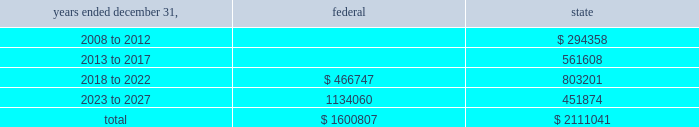American tower corporation and subsidiaries notes to consolidated financial statements 2014 ( continued ) for the years ended december 31 , 2007 and 2006 , the company increased net deferred tax assets by $ 1.5 million and $ 7.2 million , respectively with a corresponding reduction of goodwill associated with the utilization of net operating and capital losses acquired in connection with the spectrasite , inc .
Merger .
These deferred tax assets were assigned a full valuation allowance as part of the final spectrasite purchase price allocation in june 2006 , as evidence available at the time did not support that losses were more likely than not to be realized .
The valuation allowance decreased from $ 308.2 million as of december 31 , 2006 to $ 88.2 million as of december 31 , 2007 .
The decrease was primarily due to a $ 149.6 million reclassification to the fin 48 opening balance ( related to federal and state net operating losses acquired in connection with the spectrasite , inc .
Merger ) and $ 45.2 million of allowance reductions during the year ended december 31 , 2007 related to state net operating losses , capital loss expirations of $ 6.5 million and other items .
The company 2019s deferred tax assets as of december 31 , 2007 and 2006 in the table above do not include $ 74.9 million and $ 31.0 million , respectively , of excess tax benefits from the exercises of employee stock options that are a component of net operating losses due to the adoption of sfas no .
123r .
Total stockholders 2019 equity will be increased by $ 74.9 million if and when any such excess tax benefits are ultimately realized .
Basis step-up from corporate restructuring represents the tax effects of increasing the basis for tax purposes of certain of the company 2019s assets in conjunction with its spin-off from american radio systems corporation , its former parent company .
At december 31 , 2007 , the company had net federal and state operating loss carryforwards available to reduce future federal and state taxable income of approximately $ 1.6 billion and $ 2.1 billion , respectively .
If not utilized , the company 2019s net operating loss carryforwards expire as follows ( in thousands ) : .
As described in note 1 , the company adopted the provisions of fin 48 on january 1 , 2007 .
As of january 1 , 2007 , the total amount of unrecognized tax benefits was $ 183.9 million of which $ 34.3 million would affect the effective tax rate , if recognized .
As of december 31 , 2007 , the total amount of unrecognized tax benefits was $ 59.2 million , $ 23.0 million of which would affect the effective tax rate , if recognized .
The company expects the unrecognized tax benefits to change over the next 12 months if certain tax matters ultimately settle with the applicable taxing jurisdiction during this timeframe .
However , based on the status of these items and the amount of uncertainty associated with the outcome and timing of audit settlements , the .
What was the change in the total amount of unrecognized tax benefits in 2007in millions? 
Computations: (183.9 - 59.2)
Answer: 124.7. 